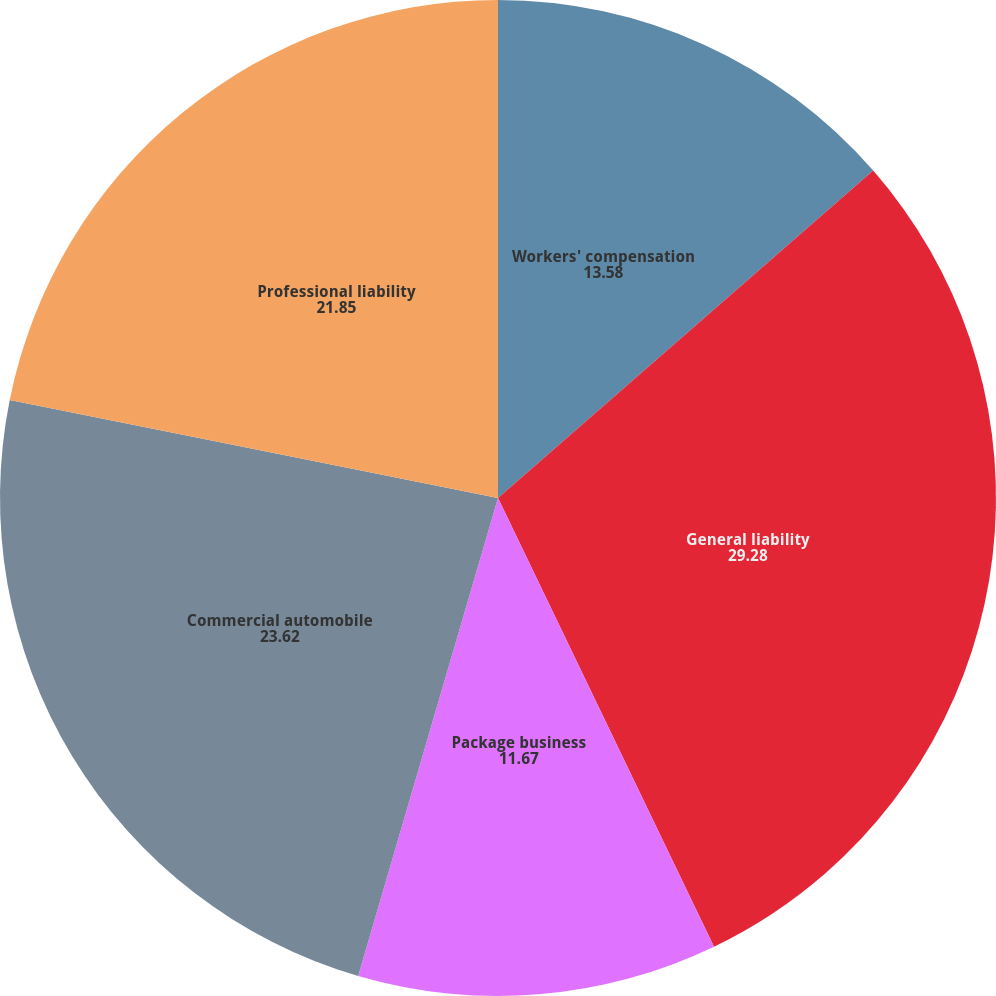Convert chart. <chart><loc_0><loc_0><loc_500><loc_500><pie_chart><fcel>Workers' compensation<fcel>General liability<fcel>Package business<fcel>Commercial automobile<fcel>Professional liability<nl><fcel>13.58%<fcel>29.28%<fcel>11.67%<fcel>23.62%<fcel>21.85%<nl></chart> 